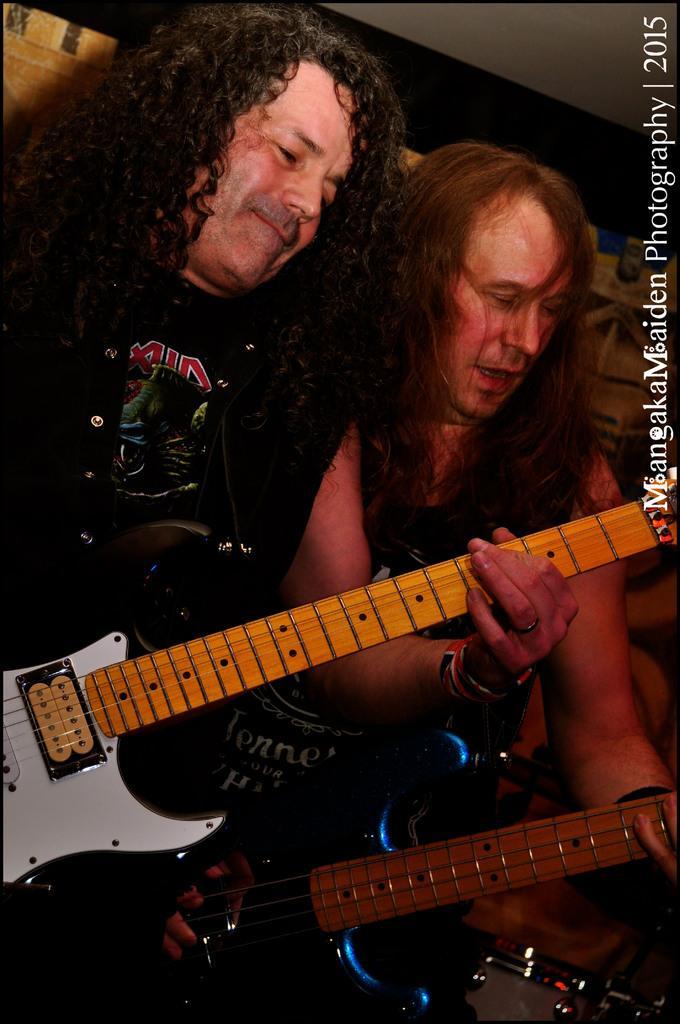Could you give a brief overview of what you see in this image? As we can see in the image there are two people holding guitars. 